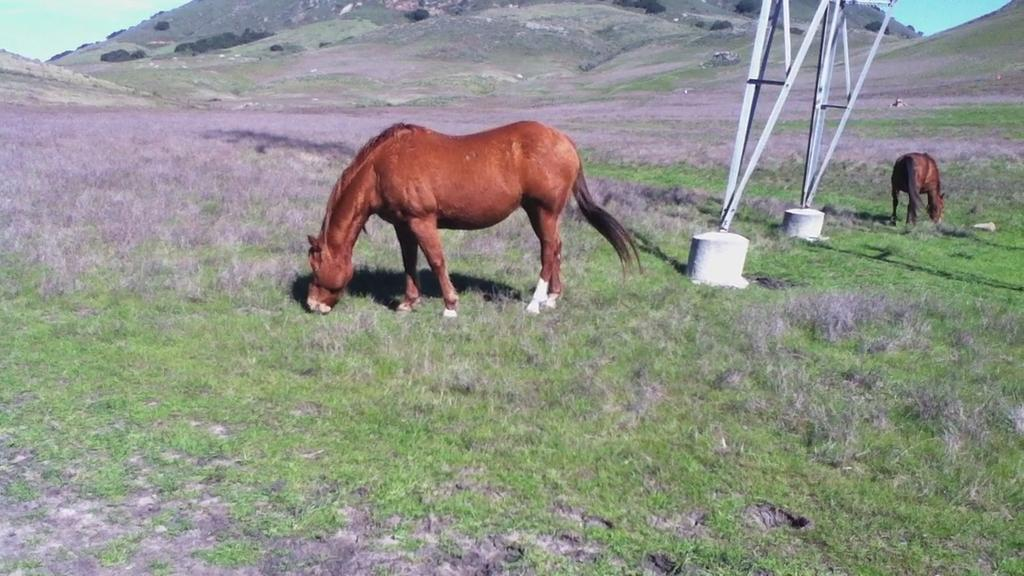What animals can be seen in the foreground of the image? There are two horses in the foreground of the image. What object is on the grass in the foreground? There is a pole on the grass in the foreground. What type of terrain is visible in the background of the image? There is a slope in the background of the image. What part of the natural environment is visible in the background of the image? The sky is visible in the background of the image. What type of toothpaste is being used by the fairies in the image? There are no fairies present in the image, and therefore no toothpaste can be observed. What type of quartz can be seen in the image? There is no quartz present in the image. 